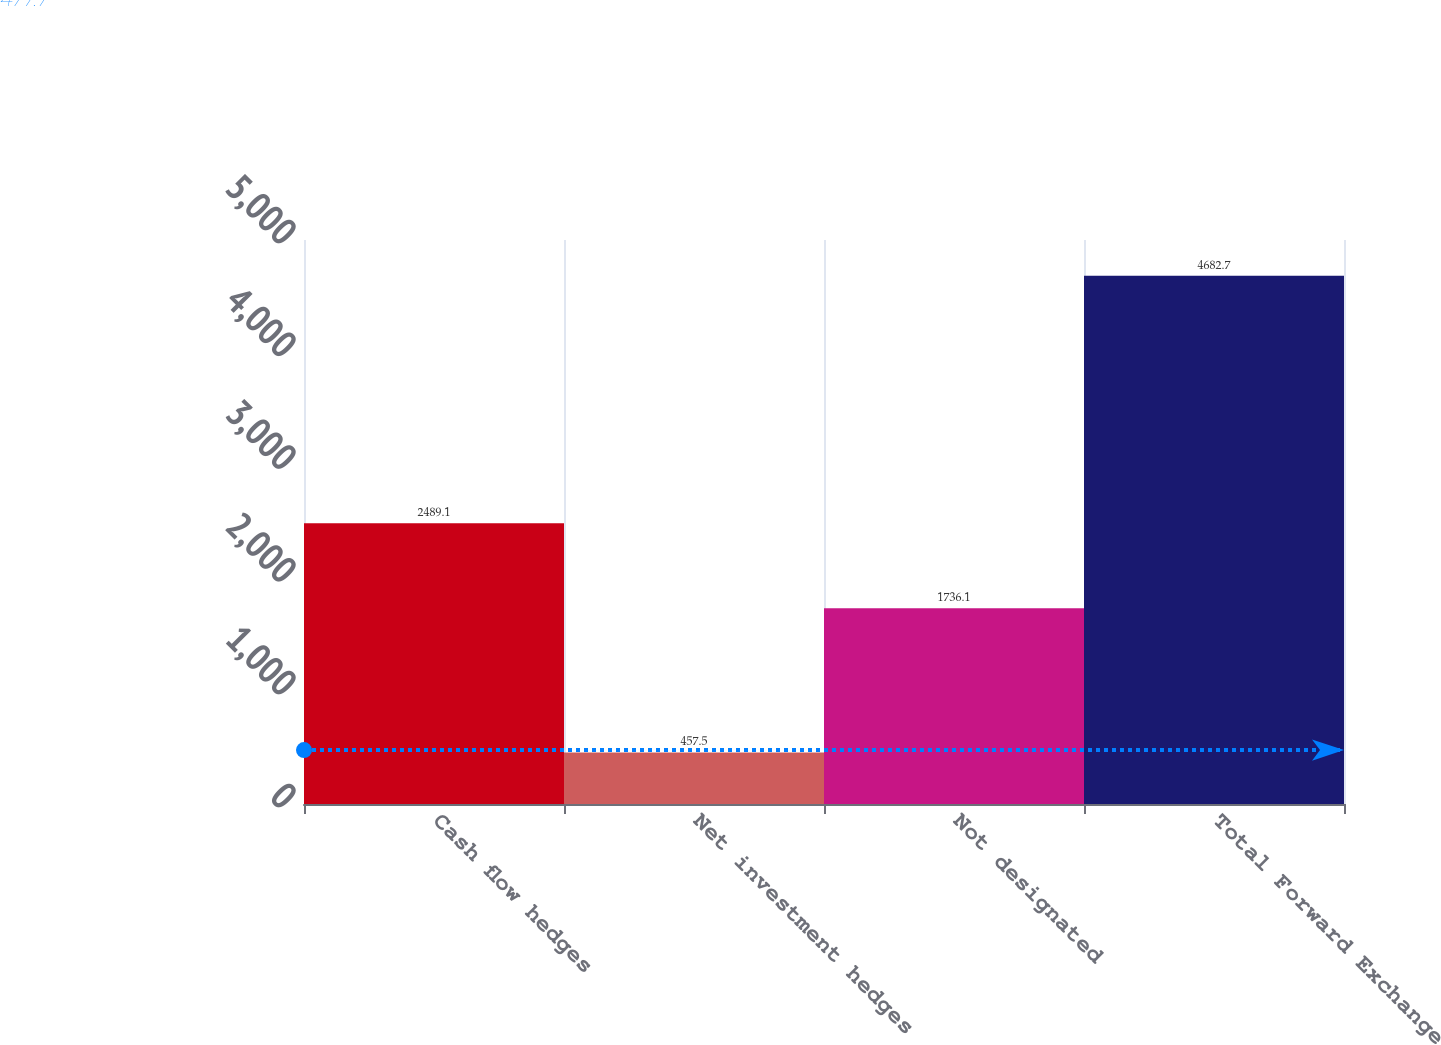<chart> <loc_0><loc_0><loc_500><loc_500><bar_chart><fcel>Cash flow hedges<fcel>Net investment hedges<fcel>Not designated<fcel>Total Forward Exchange<nl><fcel>2489.1<fcel>457.5<fcel>1736.1<fcel>4682.7<nl></chart> 